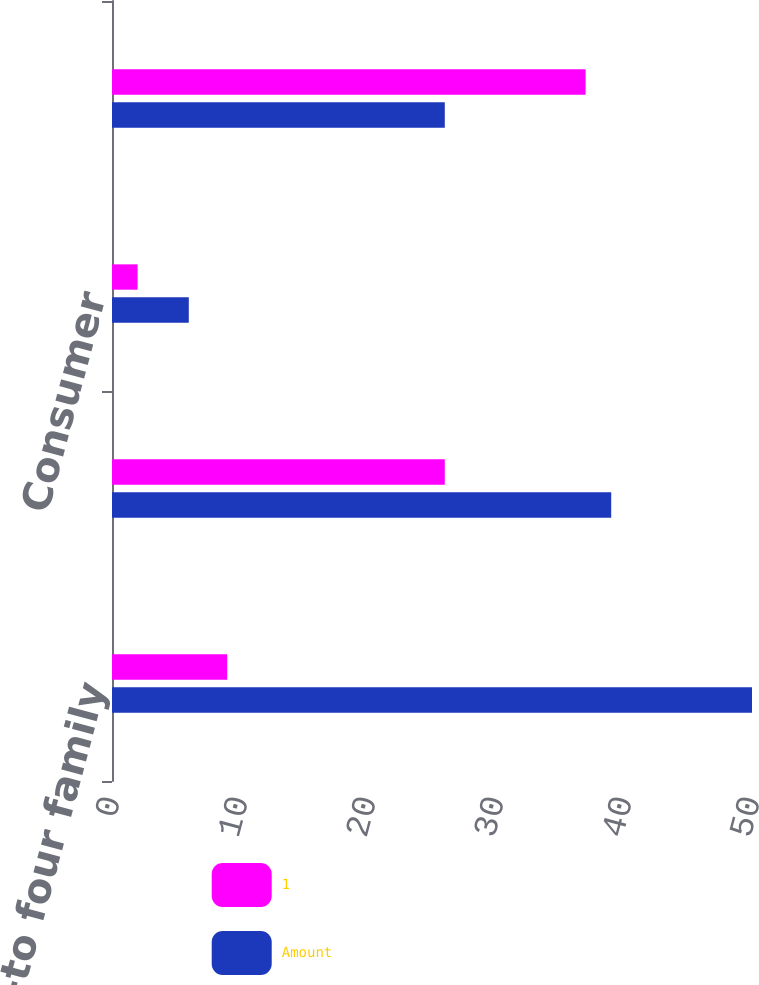Convert chart to OTSL. <chart><loc_0><loc_0><loc_500><loc_500><stacked_bar_chart><ecel><fcel>One-to four family<fcel>Home equity<fcel>Consumer<fcel>Total allowance for loan<nl><fcel>1<fcel>9<fcel>26<fcel>2<fcel>37<nl><fcel>Amount<fcel>50<fcel>39<fcel>6<fcel>26<nl></chart> 